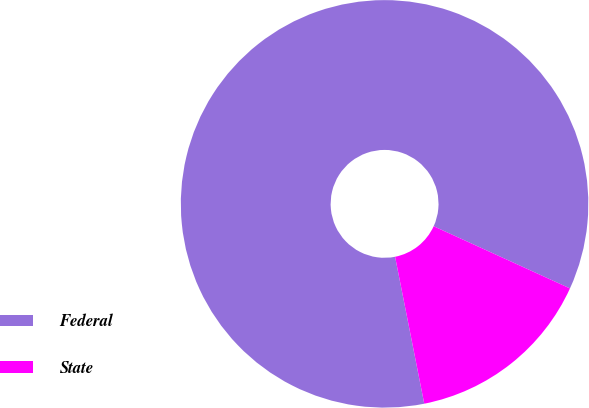<chart> <loc_0><loc_0><loc_500><loc_500><pie_chart><fcel>Federal<fcel>State<nl><fcel>84.93%<fcel>15.07%<nl></chart> 